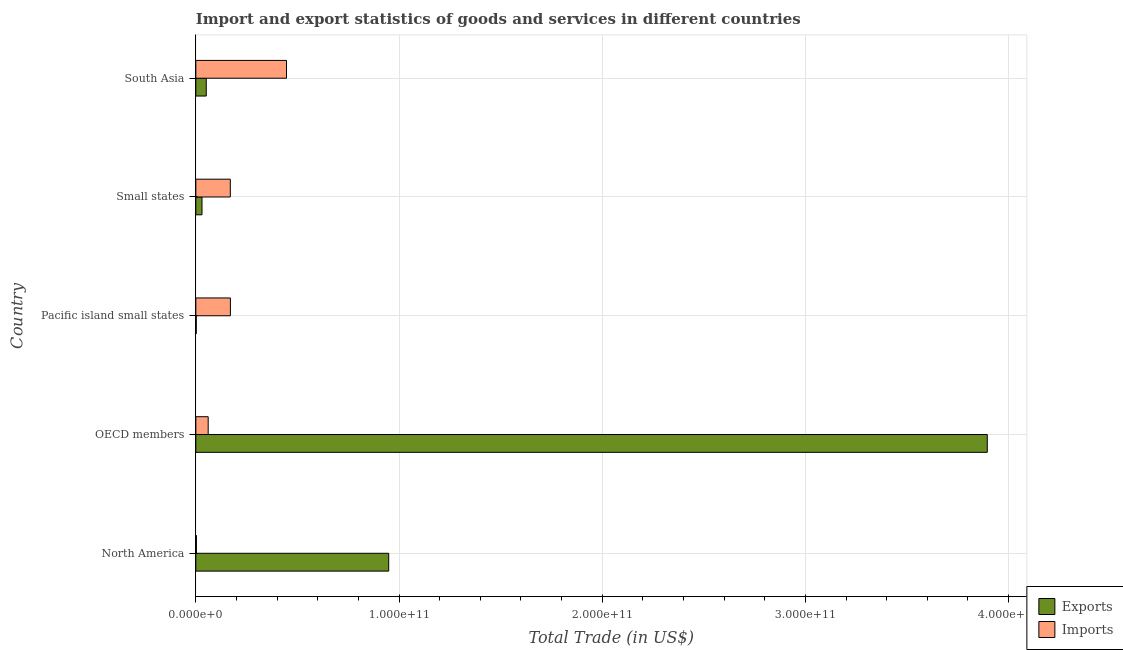How many bars are there on the 1st tick from the top?
Provide a short and direct response. 2. How many bars are there on the 1st tick from the bottom?
Keep it short and to the point. 2. What is the export of goods and services in OECD members?
Provide a short and direct response. 3.89e+11. Across all countries, what is the maximum export of goods and services?
Provide a short and direct response. 3.89e+11. Across all countries, what is the minimum export of goods and services?
Give a very brief answer. 2.09e+08. In which country was the export of goods and services maximum?
Your answer should be compact. OECD members. In which country was the export of goods and services minimum?
Your answer should be compact. Pacific island small states. What is the total export of goods and services in the graph?
Offer a terse response. 4.93e+11. What is the difference between the export of goods and services in Pacific island small states and that in Small states?
Make the answer very short. -2.83e+09. What is the difference between the imports of goods and services in Small states and the export of goods and services in OECD members?
Keep it short and to the point. -3.73e+11. What is the average export of goods and services per country?
Ensure brevity in your answer.  9.86e+1. What is the difference between the export of goods and services and imports of goods and services in Small states?
Ensure brevity in your answer.  -1.39e+1. What is the ratio of the export of goods and services in Pacific island small states to that in South Asia?
Offer a very short reply. 0.04. Is the difference between the export of goods and services in Pacific island small states and South Asia greater than the difference between the imports of goods and services in Pacific island small states and South Asia?
Your answer should be compact. Yes. What is the difference between the highest and the second highest imports of goods and services?
Provide a short and direct response. 2.76e+1. What is the difference between the highest and the lowest imports of goods and services?
Your answer should be very brief. 4.43e+1. In how many countries, is the export of goods and services greater than the average export of goods and services taken over all countries?
Give a very brief answer. 1. What does the 2nd bar from the top in OECD members represents?
Your response must be concise. Exports. What does the 1st bar from the bottom in South Asia represents?
Offer a very short reply. Exports. How many bars are there?
Make the answer very short. 10. How many countries are there in the graph?
Keep it short and to the point. 5. What is the difference between two consecutive major ticks on the X-axis?
Your answer should be very brief. 1.00e+11. Does the graph contain any zero values?
Offer a terse response. No. Where does the legend appear in the graph?
Offer a terse response. Bottom right. How many legend labels are there?
Keep it short and to the point. 2. How are the legend labels stacked?
Offer a terse response. Vertical. What is the title of the graph?
Offer a terse response. Import and export statistics of goods and services in different countries. What is the label or title of the X-axis?
Make the answer very short. Total Trade (in US$). What is the label or title of the Y-axis?
Make the answer very short. Country. What is the Total Trade (in US$) of Exports in North America?
Your answer should be compact. 9.49e+1. What is the Total Trade (in US$) of Imports in North America?
Keep it short and to the point. 2.92e+08. What is the Total Trade (in US$) in Exports in OECD members?
Provide a succinct answer. 3.89e+11. What is the Total Trade (in US$) in Imports in OECD members?
Give a very brief answer. 6.08e+09. What is the Total Trade (in US$) of Exports in Pacific island small states?
Offer a terse response. 2.09e+08. What is the Total Trade (in US$) of Imports in Pacific island small states?
Offer a terse response. 1.70e+1. What is the Total Trade (in US$) of Exports in Small states?
Give a very brief answer. 3.04e+09. What is the Total Trade (in US$) in Imports in Small states?
Provide a short and direct response. 1.70e+1. What is the Total Trade (in US$) of Exports in South Asia?
Keep it short and to the point. 5.14e+09. What is the Total Trade (in US$) of Imports in South Asia?
Keep it short and to the point. 4.46e+1. Across all countries, what is the maximum Total Trade (in US$) in Exports?
Give a very brief answer. 3.89e+11. Across all countries, what is the maximum Total Trade (in US$) in Imports?
Offer a very short reply. 4.46e+1. Across all countries, what is the minimum Total Trade (in US$) in Exports?
Make the answer very short. 2.09e+08. Across all countries, what is the minimum Total Trade (in US$) in Imports?
Your response must be concise. 2.92e+08. What is the total Total Trade (in US$) of Exports in the graph?
Your answer should be compact. 4.93e+11. What is the total Total Trade (in US$) in Imports in the graph?
Ensure brevity in your answer.  8.50e+1. What is the difference between the Total Trade (in US$) in Exports in North America and that in OECD members?
Give a very brief answer. -2.95e+11. What is the difference between the Total Trade (in US$) of Imports in North America and that in OECD members?
Offer a very short reply. -5.79e+09. What is the difference between the Total Trade (in US$) of Exports in North America and that in Pacific island small states?
Your answer should be compact. 9.47e+1. What is the difference between the Total Trade (in US$) in Imports in North America and that in Pacific island small states?
Make the answer very short. -1.67e+1. What is the difference between the Total Trade (in US$) of Exports in North America and that in Small states?
Your answer should be compact. 9.19e+1. What is the difference between the Total Trade (in US$) in Imports in North America and that in Small states?
Offer a very short reply. -1.67e+1. What is the difference between the Total Trade (in US$) in Exports in North America and that in South Asia?
Make the answer very short. 8.98e+1. What is the difference between the Total Trade (in US$) in Imports in North America and that in South Asia?
Your answer should be very brief. -4.43e+1. What is the difference between the Total Trade (in US$) of Exports in OECD members and that in Pacific island small states?
Your response must be concise. 3.89e+11. What is the difference between the Total Trade (in US$) of Imports in OECD members and that in Pacific island small states?
Your answer should be compact. -1.09e+1. What is the difference between the Total Trade (in US$) of Exports in OECD members and that in Small states?
Offer a very short reply. 3.86e+11. What is the difference between the Total Trade (in US$) in Imports in OECD members and that in Small states?
Your answer should be very brief. -1.09e+1. What is the difference between the Total Trade (in US$) of Exports in OECD members and that in South Asia?
Provide a short and direct response. 3.84e+11. What is the difference between the Total Trade (in US$) in Imports in OECD members and that in South Asia?
Your response must be concise. -3.85e+1. What is the difference between the Total Trade (in US$) of Exports in Pacific island small states and that in Small states?
Provide a short and direct response. -2.83e+09. What is the difference between the Total Trade (in US$) of Imports in Pacific island small states and that in Small states?
Give a very brief answer. 3.97e+07. What is the difference between the Total Trade (in US$) of Exports in Pacific island small states and that in South Asia?
Offer a very short reply. -4.93e+09. What is the difference between the Total Trade (in US$) in Imports in Pacific island small states and that in South Asia?
Make the answer very short. -2.76e+1. What is the difference between the Total Trade (in US$) in Exports in Small states and that in South Asia?
Provide a succinct answer. -2.10e+09. What is the difference between the Total Trade (in US$) in Imports in Small states and that in South Asia?
Give a very brief answer. -2.77e+1. What is the difference between the Total Trade (in US$) in Exports in North America and the Total Trade (in US$) in Imports in OECD members?
Offer a very short reply. 8.88e+1. What is the difference between the Total Trade (in US$) of Exports in North America and the Total Trade (in US$) of Imports in Pacific island small states?
Make the answer very short. 7.79e+1. What is the difference between the Total Trade (in US$) of Exports in North America and the Total Trade (in US$) of Imports in Small states?
Your response must be concise. 7.80e+1. What is the difference between the Total Trade (in US$) in Exports in North America and the Total Trade (in US$) in Imports in South Asia?
Your answer should be very brief. 5.03e+1. What is the difference between the Total Trade (in US$) in Exports in OECD members and the Total Trade (in US$) in Imports in Pacific island small states?
Your response must be concise. 3.72e+11. What is the difference between the Total Trade (in US$) of Exports in OECD members and the Total Trade (in US$) of Imports in Small states?
Provide a short and direct response. 3.73e+11. What is the difference between the Total Trade (in US$) of Exports in OECD members and the Total Trade (in US$) of Imports in South Asia?
Keep it short and to the point. 3.45e+11. What is the difference between the Total Trade (in US$) of Exports in Pacific island small states and the Total Trade (in US$) of Imports in Small states?
Ensure brevity in your answer.  -1.68e+1. What is the difference between the Total Trade (in US$) of Exports in Pacific island small states and the Total Trade (in US$) of Imports in South Asia?
Keep it short and to the point. -4.44e+1. What is the difference between the Total Trade (in US$) of Exports in Small states and the Total Trade (in US$) of Imports in South Asia?
Your answer should be very brief. -4.16e+1. What is the average Total Trade (in US$) in Exports per country?
Make the answer very short. 9.86e+1. What is the average Total Trade (in US$) in Imports per country?
Keep it short and to the point. 1.70e+1. What is the difference between the Total Trade (in US$) of Exports and Total Trade (in US$) of Imports in North America?
Keep it short and to the point. 9.46e+1. What is the difference between the Total Trade (in US$) of Exports and Total Trade (in US$) of Imports in OECD members?
Keep it short and to the point. 3.83e+11. What is the difference between the Total Trade (in US$) of Exports and Total Trade (in US$) of Imports in Pacific island small states?
Provide a short and direct response. -1.68e+1. What is the difference between the Total Trade (in US$) of Exports and Total Trade (in US$) of Imports in Small states?
Ensure brevity in your answer.  -1.39e+1. What is the difference between the Total Trade (in US$) in Exports and Total Trade (in US$) in Imports in South Asia?
Your answer should be very brief. -3.95e+1. What is the ratio of the Total Trade (in US$) in Exports in North America to that in OECD members?
Your response must be concise. 0.24. What is the ratio of the Total Trade (in US$) of Imports in North America to that in OECD members?
Keep it short and to the point. 0.05. What is the ratio of the Total Trade (in US$) of Exports in North America to that in Pacific island small states?
Your answer should be very brief. 455.02. What is the ratio of the Total Trade (in US$) of Imports in North America to that in Pacific island small states?
Offer a terse response. 0.02. What is the ratio of the Total Trade (in US$) in Exports in North America to that in Small states?
Offer a terse response. 31.22. What is the ratio of the Total Trade (in US$) of Imports in North America to that in Small states?
Provide a succinct answer. 0.02. What is the ratio of the Total Trade (in US$) in Exports in North America to that in South Asia?
Offer a very short reply. 18.47. What is the ratio of the Total Trade (in US$) of Imports in North America to that in South Asia?
Offer a terse response. 0.01. What is the ratio of the Total Trade (in US$) of Exports in OECD members to that in Pacific island small states?
Your answer should be compact. 1867.06. What is the ratio of the Total Trade (in US$) in Imports in OECD members to that in Pacific island small states?
Provide a succinct answer. 0.36. What is the ratio of the Total Trade (in US$) of Exports in OECD members to that in Small states?
Your answer should be compact. 128.09. What is the ratio of the Total Trade (in US$) of Imports in OECD members to that in Small states?
Your response must be concise. 0.36. What is the ratio of the Total Trade (in US$) in Exports in OECD members to that in South Asia?
Your response must be concise. 75.78. What is the ratio of the Total Trade (in US$) in Imports in OECD members to that in South Asia?
Ensure brevity in your answer.  0.14. What is the ratio of the Total Trade (in US$) in Exports in Pacific island small states to that in Small states?
Your response must be concise. 0.07. What is the ratio of the Total Trade (in US$) of Exports in Pacific island small states to that in South Asia?
Ensure brevity in your answer.  0.04. What is the ratio of the Total Trade (in US$) in Imports in Pacific island small states to that in South Asia?
Offer a terse response. 0.38. What is the ratio of the Total Trade (in US$) of Exports in Small states to that in South Asia?
Your response must be concise. 0.59. What is the ratio of the Total Trade (in US$) of Imports in Small states to that in South Asia?
Ensure brevity in your answer.  0.38. What is the difference between the highest and the second highest Total Trade (in US$) in Exports?
Keep it short and to the point. 2.95e+11. What is the difference between the highest and the second highest Total Trade (in US$) of Imports?
Your response must be concise. 2.76e+1. What is the difference between the highest and the lowest Total Trade (in US$) in Exports?
Your answer should be very brief. 3.89e+11. What is the difference between the highest and the lowest Total Trade (in US$) of Imports?
Keep it short and to the point. 4.43e+1. 